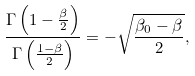<formula> <loc_0><loc_0><loc_500><loc_500>\frac { \Gamma \left ( 1 - \frac { \beta } { 2 } \right ) } { \Gamma \left ( \frac { 1 - \beta } { 2 } \right ) } = - \sqrt { \frac { \beta _ { 0 } - \beta } { 2 } } ,</formula> 